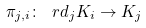<formula> <loc_0><loc_0><loc_500><loc_500>\pi _ { j , i } \colon \ r d _ { j } K _ { i } \to K _ { j }</formula> 